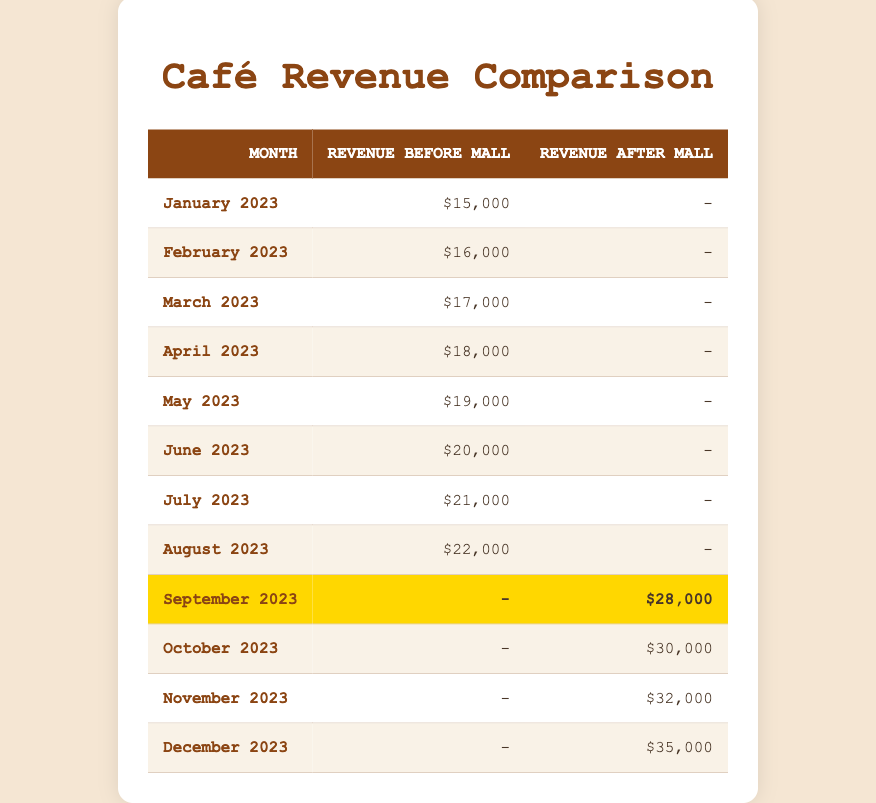What was the total revenue generated in October 2023? The revenue after the mall opening in October 2023 was $30,000, and there was no revenue before the mall opened that month. Hence, the total revenue for October 2023 is just the after-mall revenue, which is $30,000.
Answer: 30000 What was the average revenue before the mall opened from January to August 2023? The revenues before the mall opened from January to August 2023 are $15,000, $16,000, $17,000, $18,000, $19,000, $20,000, $21,000, and $22,000. To find the average, we first sum these values: 15,000 + 16,000 + 17,000 + 18,000 + 19,000 + 20,000 + 21,000 + 22,000 = 128,000. Then, we divide by the number of months (8), which gives us an average of 128,000 / 8 = 16,000.
Answer: 16000 In which month did the café start to generate revenue after the mall opened? The café started to generate revenue after the mall opened in September 2023, as the first entry in the ‘Revenue After Mall’ column is for that month with $28,000.
Answer: September 2023 Is the revenue after the mall opened higher than $30,000 for all months following its opening? To answer this, we check the revenues after the mall opened: $28,000 for September, $30,000 for October, $32,000 for November, and $35,000 for December. Since September's revenue is less than $30,000, the statement is false.
Answer: No What was the revenue increase from August 2023 to September 2023? The revenue for August 2023 before the mall was $22,000, and after the mall opened in September 2023, it was $28,000. To find the increase, we consider only the after-mall revenue in September, which is $28,000. The increase is calculated as $28,000 - $22,000 = $6,000.
Answer: 6000 What is the total revenue made after the mall opened from September to December 2023? The revenues after the mall opened are $28,000 in September, $30,000 in October, $32,000 in November, and $35,000 in December. We sum these values: $28,000 + $30,000 + $32,000 + $35,000 = $125,000. Therefore, the total revenue made after the mall opened from September to December 2023 is $125,000.
Answer: 125000 Did the café generate any revenue before the mall opened in the months of September to December 2023? According to the table, the revenues for September to December 2023 before the mall opened are all listed as $0. Therefore, it is true that the café did not generate any revenue in those months before the mall opened.
Answer: Yes What was the trend in revenue before the mall opened from January to August 2023? The revenues from January to August 2023 show a consistent increase month-over-month, starting from $15,000 in January and reaching $22,000 in August. This indicates that the trend was upward as revenue increased each month.
Answer: Upward trend 